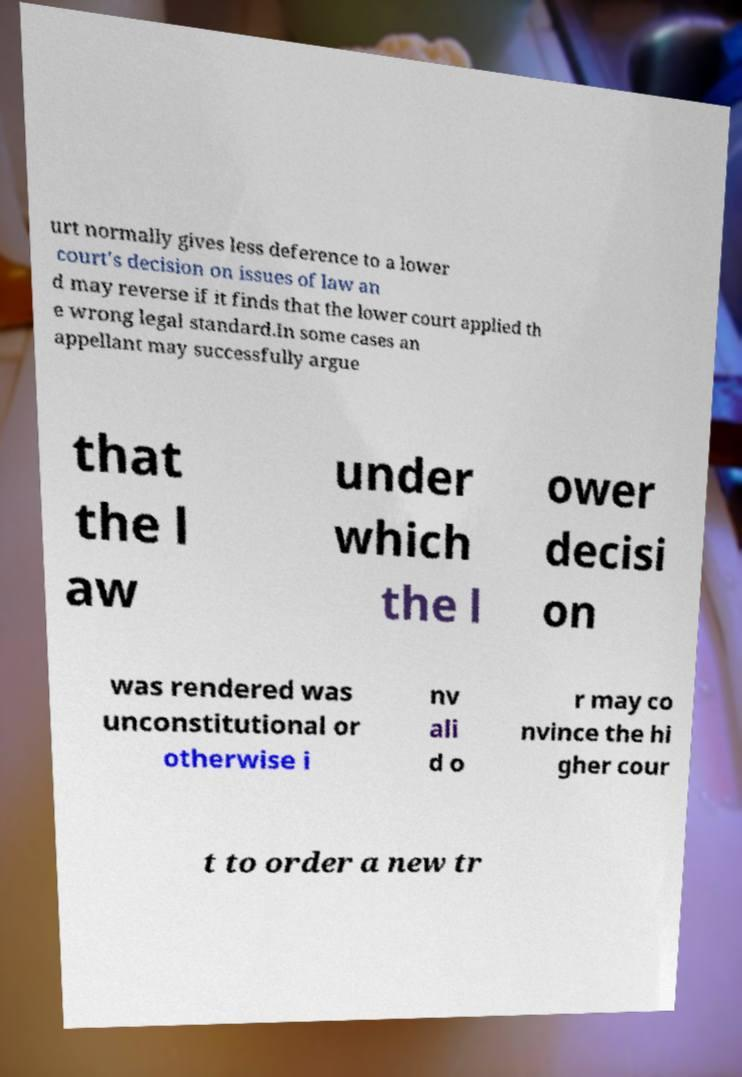What messages or text are displayed in this image? I need them in a readable, typed format. urt normally gives less deference to a lower court's decision on issues of law an d may reverse if it finds that the lower court applied th e wrong legal standard.In some cases an appellant may successfully argue that the l aw under which the l ower decisi on was rendered was unconstitutional or otherwise i nv ali d o r may co nvince the hi gher cour t to order a new tr 